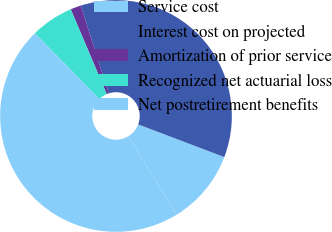<chart> <loc_0><loc_0><loc_500><loc_500><pie_chart><fcel>Service cost<fcel>Interest cost on projected<fcel>Amortization of prior service<fcel>Recognized net actuarial loss<fcel>Net postretirement benefits<nl><fcel>10.46%<fcel>35.69%<fcel>1.47%<fcel>5.96%<fcel>46.42%<nl></chart> 